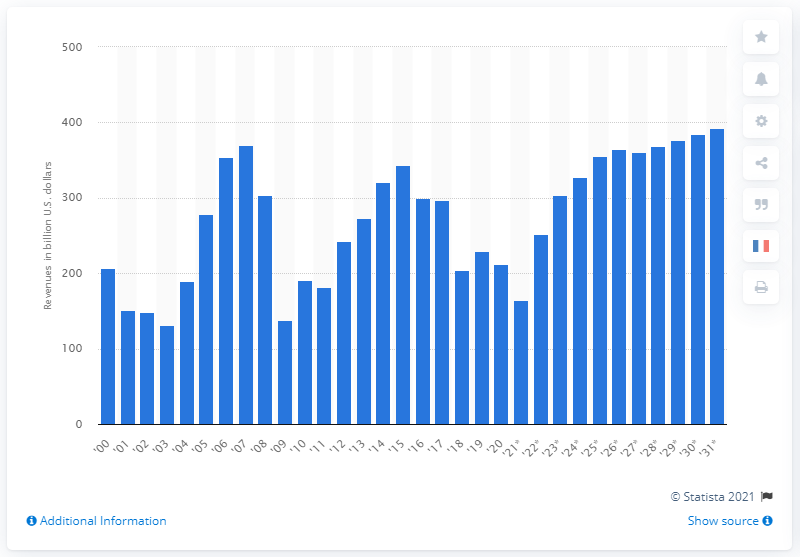Draw attention to some important aspects in this diagram. The expected increase in corporate income tax revenue in 2031 is projected to be 393. In 2020, the corporate income tax revenue in the United States was approximately $212 billion. 